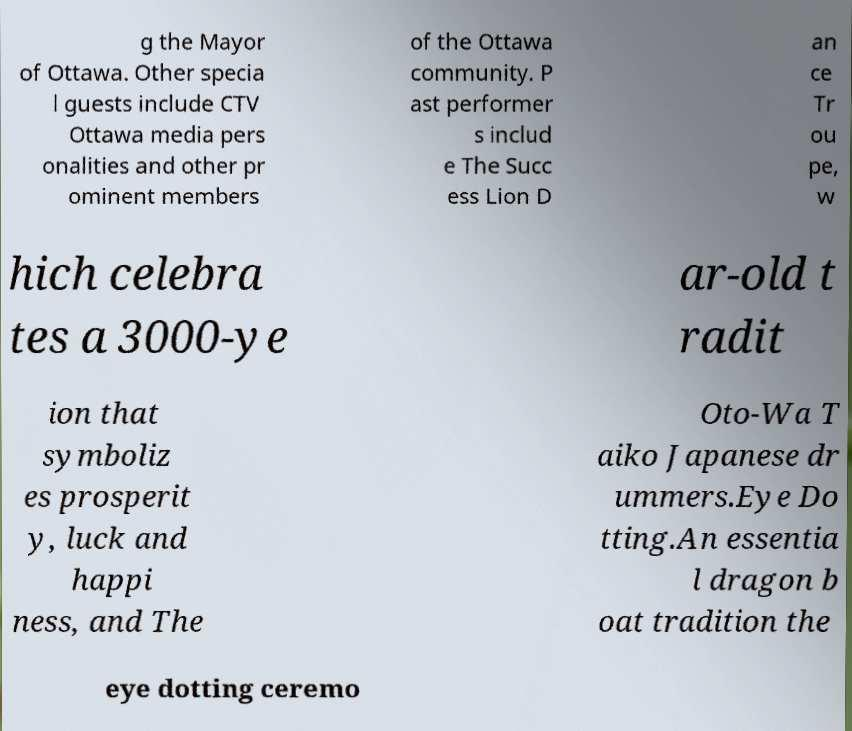Please identify and transcribe the text found in this image. g the Mayor of Ottawa. Other specia l guests include CTV Ottawa media pers onalities and other pr ominent members of the Ottawa community. P ast performer s includ e The Succ ess Lion D an ce Tr ou pe, w hich celebra tes a 3000-ye ar-old t radit ion that symboliz es prosperit y, luck and happi ness, and The Oto-Wa T aiko Japanese dr ummers.Eye Do tting.An essentia l dragon b oat tradition the eye dotting ceremo 